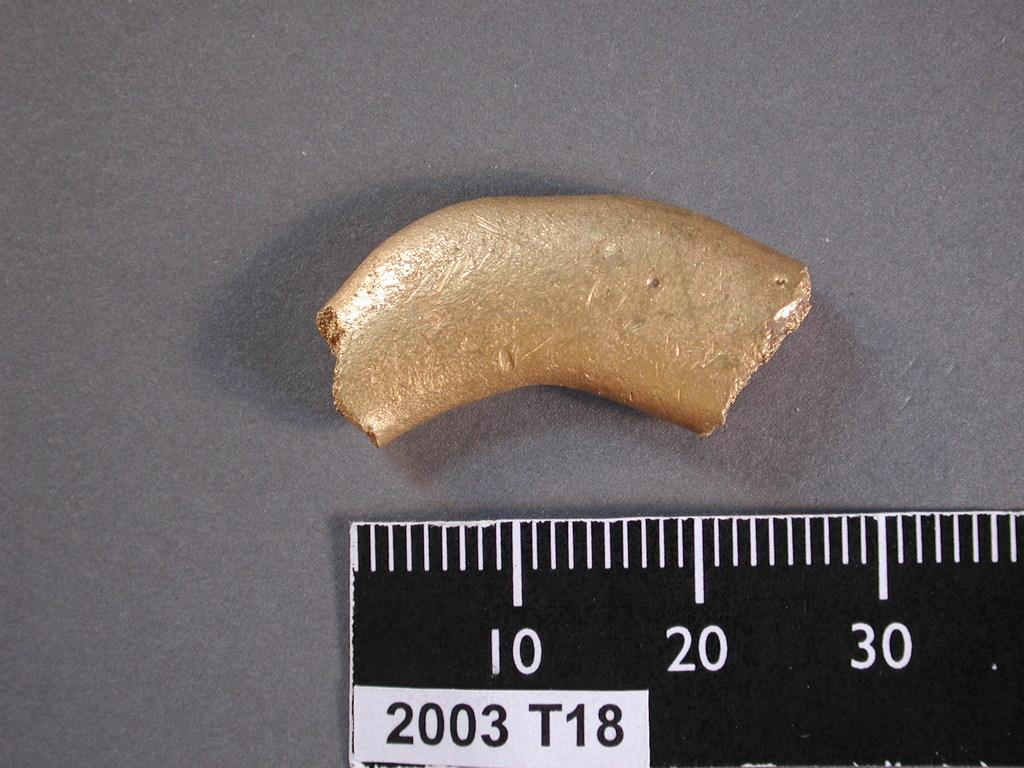What type of object is in the image? There is a piece of metal in the image. What is the purpose of the other object in the image? There is a scale in the image, which is used for measuring weight. Can you describe the position of the scale in the image? The scale is placed on a surface. What type of weather can be seen in the image? There is no weather visible in the image, as it features a piece of metal and a scale. What is the result of adding 2 and 34 on the scale in the image? There is no addition or mathematical operation being performed on the scale in the image. 